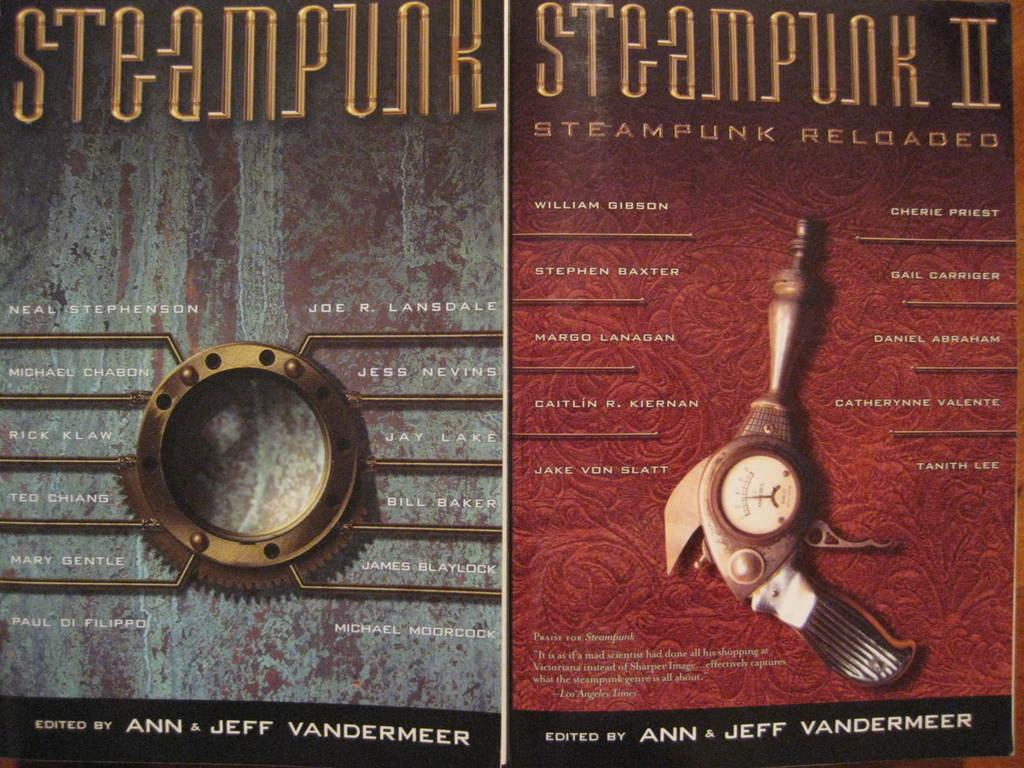<image>
Offer a succinct explanation of the picture presented. Books about Steampunk were edited by Ann and Jeff Vandermeer. 